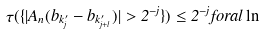<formula> <loc_0><loc_0><loc_500><loc_500>\tau ( \{ | A _ { n } ( b _ { k _ { j } ^ { \prime } } - b _ { k _ { j + l } ^ { \prime } } ) | > 2 ^ { - j } \} ) \leq 2 ^ { - j } f o r a l \ln</formula> 